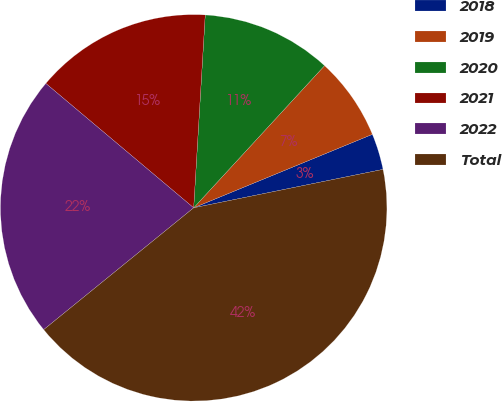<chart> <loc_0><loc_0><loc_500><loc_500><pie_chart><fcel>2018<fcel>2019<fcel>2020<fcel>2021<fcel>2022<fcel>Total<nl><fcel>3.02%<fcel>6.95%<fcel>10.89%<fcel>14.82%<fcel>21.99%<fcel>42.33%<nl></chart> 